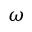Convert formula to latex. <formula><loc_0><loc_0><loc_500><loc_500>\omega</formula> 